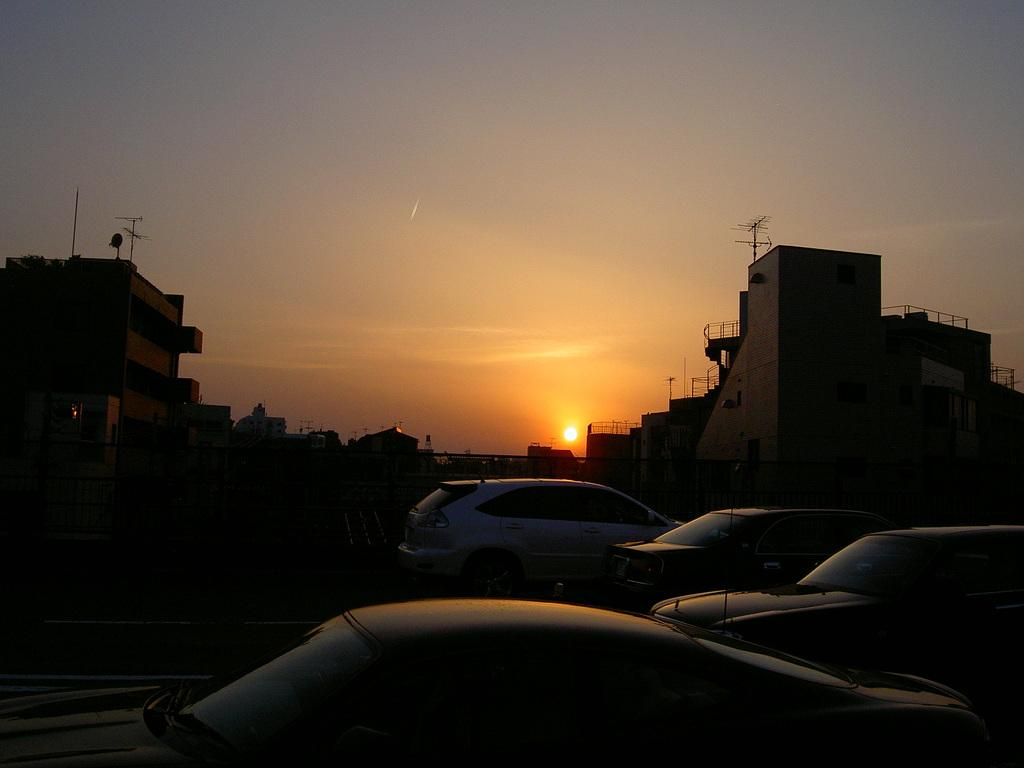What type of vehicles can be seen on the road in the image? There are cars on the road in the image. What structures are visible in the image? There are buildings in the image. What can be seen in the background of the image? The sky is visible in the background of the image. What celestial body is observable in the sky? The sun is observable in the sky. What type of title is the cow holding in its mouth in the image? There is no cow or title present in the image. How many bites has the cow taken out of the title? There is no cow or title present in the image, so it is not possible to determine how many bites have been taken. 